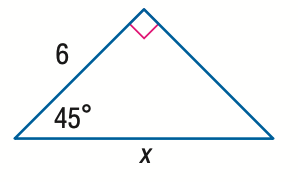Question: Find x.
Choices:
A. 6 \sqrt 2
B. 6 \sqrt { 3 }
C. 12
D. 6 \sqrt { 6 }
Answer with the letter. Answer: A 